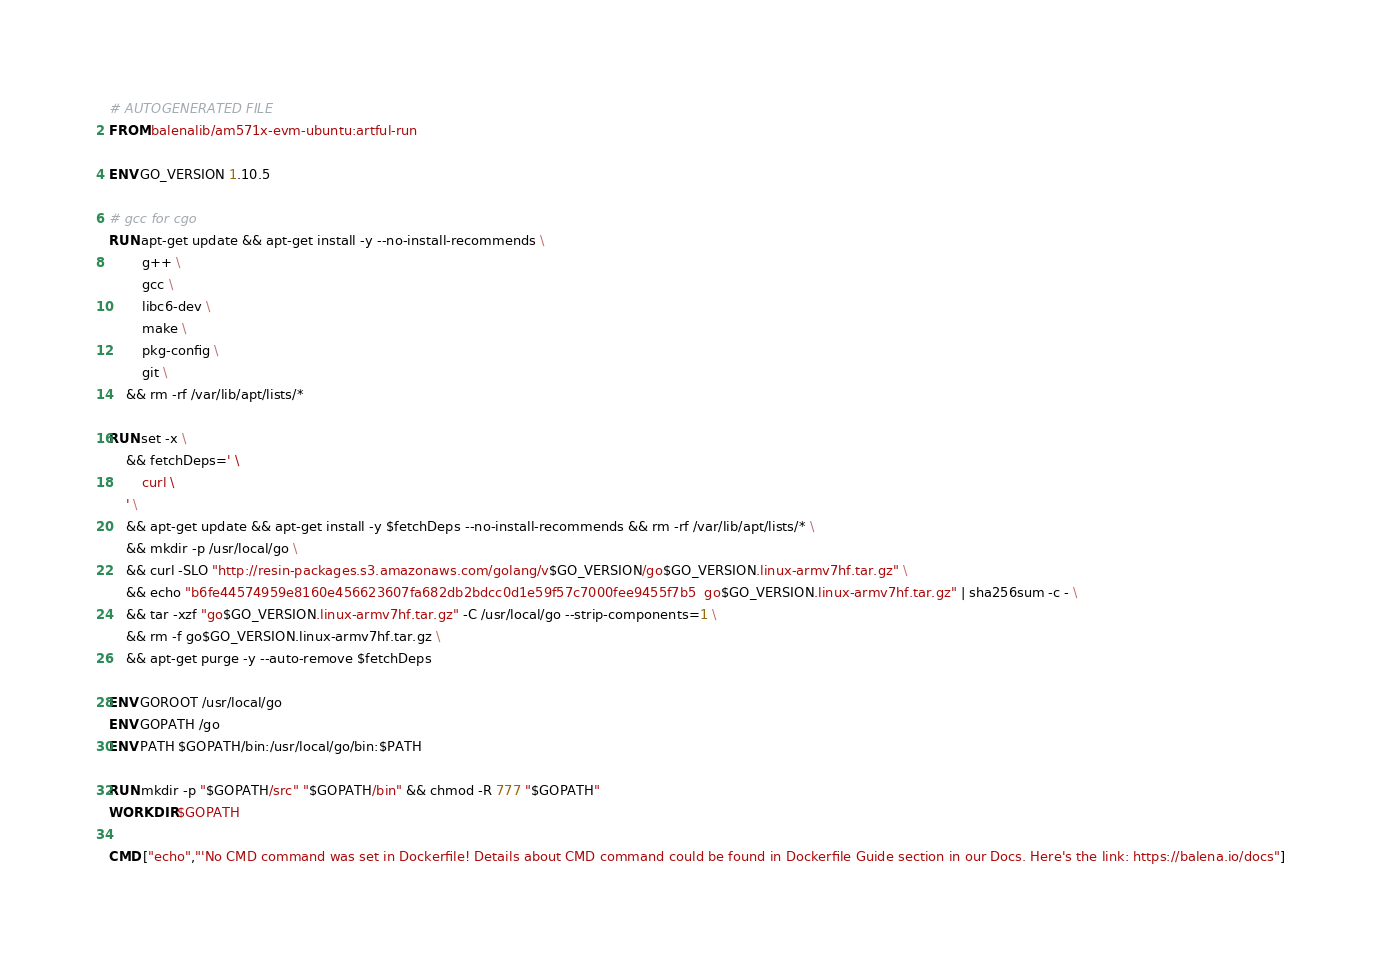<code> <loc_0><loc_0><loc_500><loc_500><_Dockerfile_># AUTOGENERATED FILE
FROM balenalib/am571x-evm-ubuntu:artful-run

ENV GO_VERSION 1.10.5

# gcc for cgo
RUN apt-get update && apt-get install -y --no-install-recommends \
		g++ \
		gcc \
		libc6-dev \
		make \
		pkg-config \
		git \
	&& rm -rf /var/lib/apt/lists/*

RUN set -x \
	&& fetchDeps=' \
		curl \
	' \
	&& apt-get update && apt-get install -y $fetchDeps --no-install-recommends && rm -rf /var/lib/apt/lists/* \
	&& mkdir -p /usr/local/go \
	&& curl -SLO "http://resin-packages.s3.amazonaws.com/golang/v$GO_VERSION/go$GO_VERSION.linux-armv7hf.tar.gz" \
	&& echo "b6fe44574959e8160e456623607fa682db2bdcc0d1e59f57c7000fee9455f7b5  go$GO_VERSION.linux-armv7hf.tar.gz" | sha256sum -c - \
	&& tar -xzf "go$GO_VERSION.linux-armv7hf.tar.gz" -C /usr/local/go --strip-components=1 \
	&& rm -f go$GO_VERSION.linux-armv7hf.tar.gz \
	&& apt-get purge -y --auto-remove $fetchDeps

ENV GOROOT /usr/local/go
ENV GOPATH /go
ENV PATH $GOPATH/bin:/usr/local/go/bin:$PATH

RUN mkdir -p "$GOPATH/src" "$GOPATH/bin" && chmod -R 777 "$GOPATH"
WORKDIR $GOPATH

CMD ["echo","'No CMD command was set in Dockerfile! Details about CMD command could be found in Dockerfile Guide section in our Docs. Here's the link: https://balena.io/docs"]</code> 